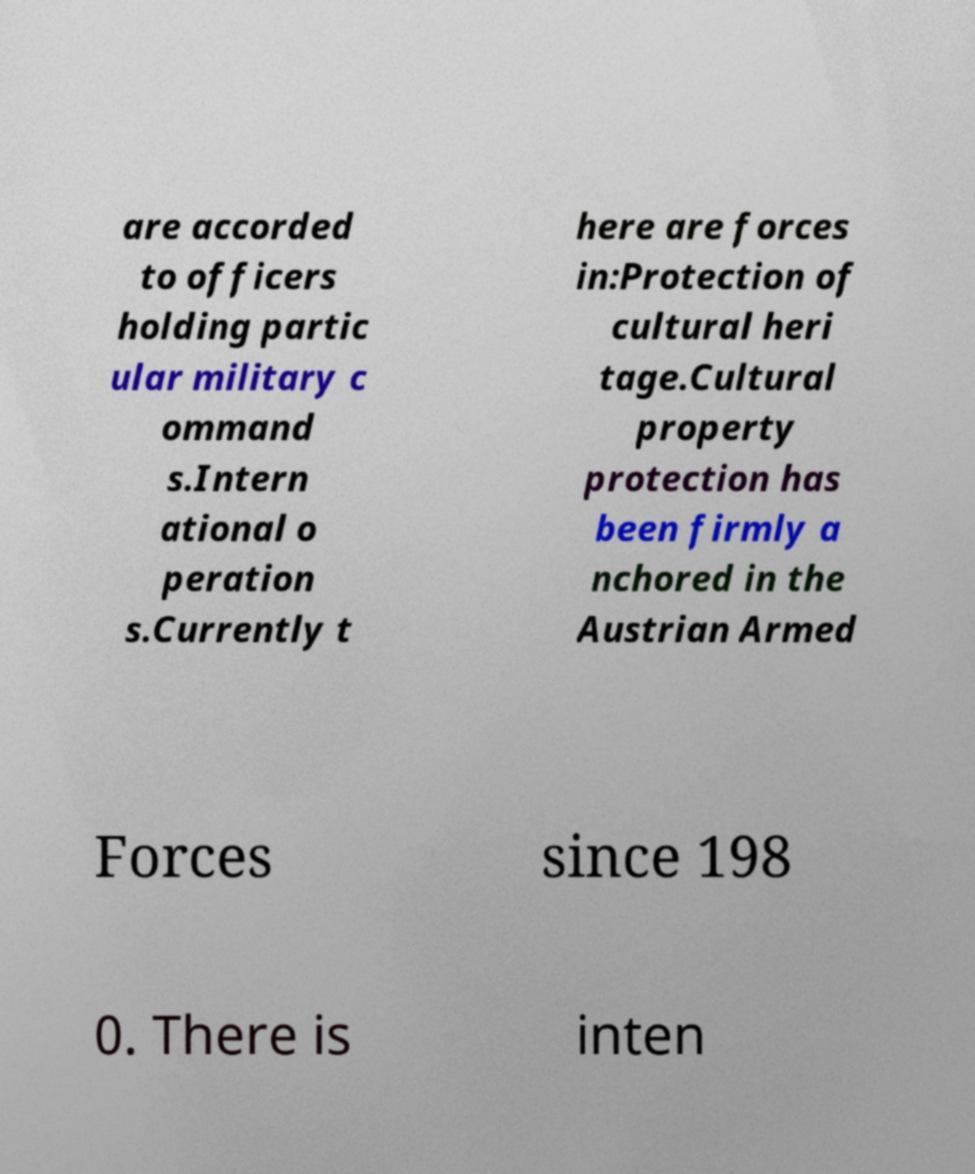I need the written content from this picture converted into text. Can you do that? are accorded to officers holding partic ular military c ommand s.Intern ational o peration s.Currently t here are forces in:Protection of cultural heri tage.Cultural property protection has been firmly a nchored in the Austrian Armed Forces since 198 0. There is inten 